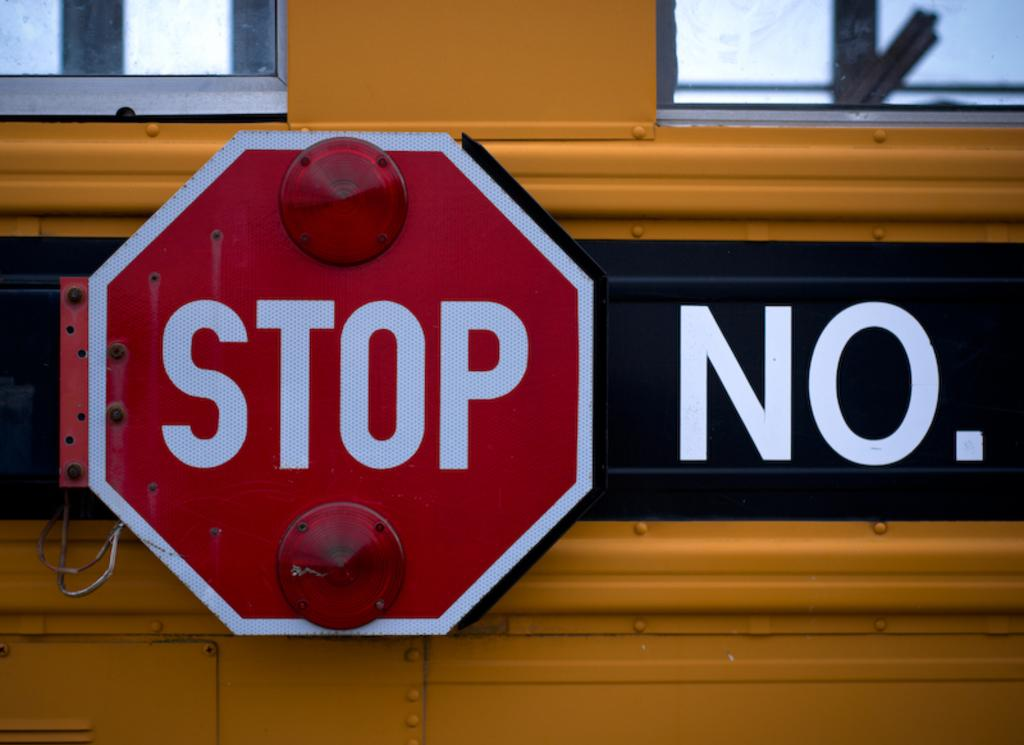Provide a one-sentence caption for the provided image. The stop sign attached to a bus is located next to the bus' number. 